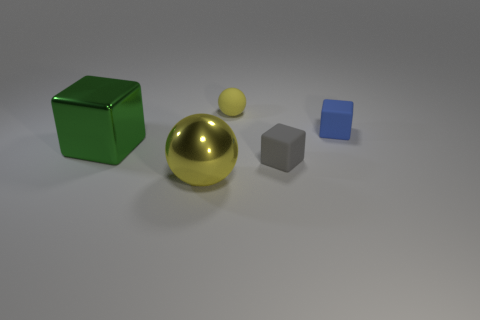Add 2 big yellow balls. How many objects exist? 7 Subtract all blocks. How many objects are left? 2 Subtract all metallic objects. Subtract all tiny yellow objects. How many objects are left? 2 Add 1 big cubes. How many big cubes are left? 2 Add 5 small blue matte things. How many small blue matte things exist? 6 Subtract 0 brown balls. How many objects are left? 5 